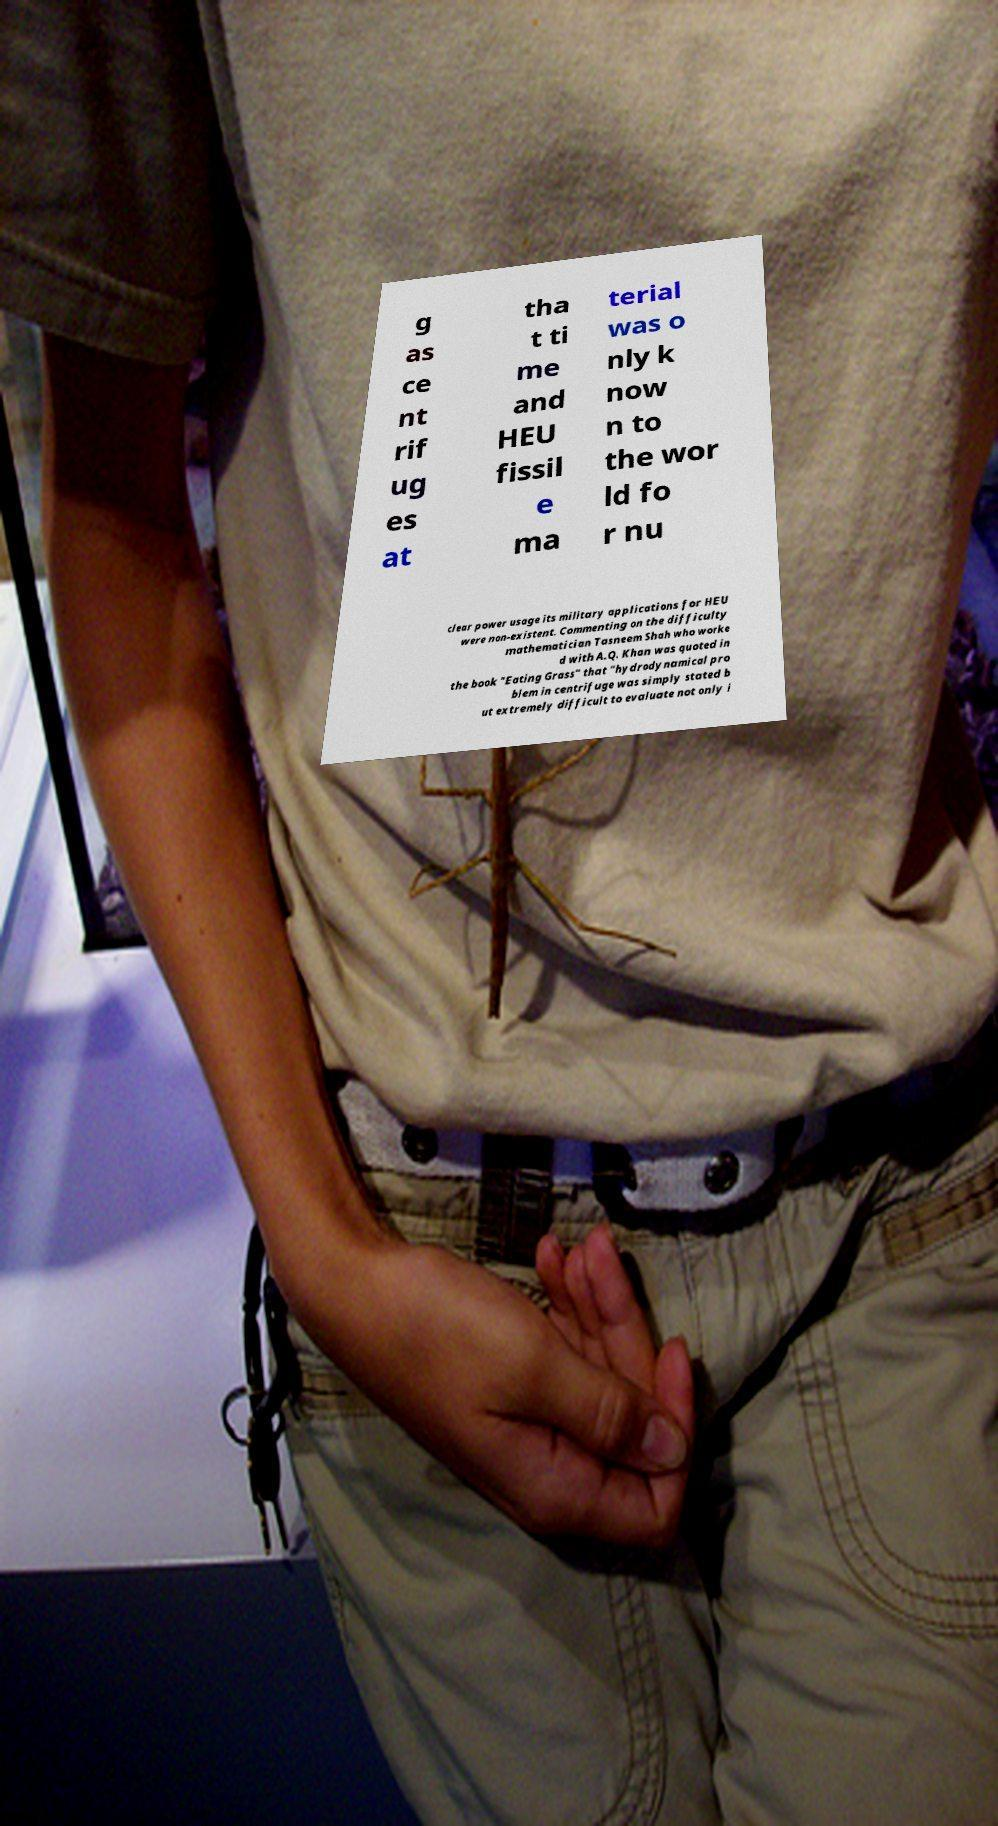For documentation purposes, I need the text within this image transcribed. Could you provide that? g as ce nt rif ug es at tha t ti me and HEU fissil e ma terial was o nly k now n to the wor ld fo r nu clear power usage its military applications for HEU were non-existent. Commenting on the difficulty mathematician Tasneem Shah who worke d with A.Q. Khan was quoted in the book "Eating Grass" that "hydrodynamical pro blem in centrifuge was simply stated b ut extremely difficult to evaluate not only i 